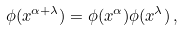Convert formula to latex. <formula><loc_0><loc_0><loc_500><loc_500>\phi ( x ^ { \alpha + \lambda } ) = \phi ( x ^ { \alpha } ) \phi ( x ^ { \lambda } ) \, ,</formula> 